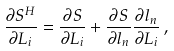<formula> <loc_0><loc_0><loc_500><loc_500>\frac { \partial S ^ { H } } { \partial L _ { i } } = \frac { \partial S } { \partial L _ { i } } + \frac { \partial S } { \partial l _ { n } } \frac { \partial l _ { n } } { \partial L _ { i } } \, ,</formula> 